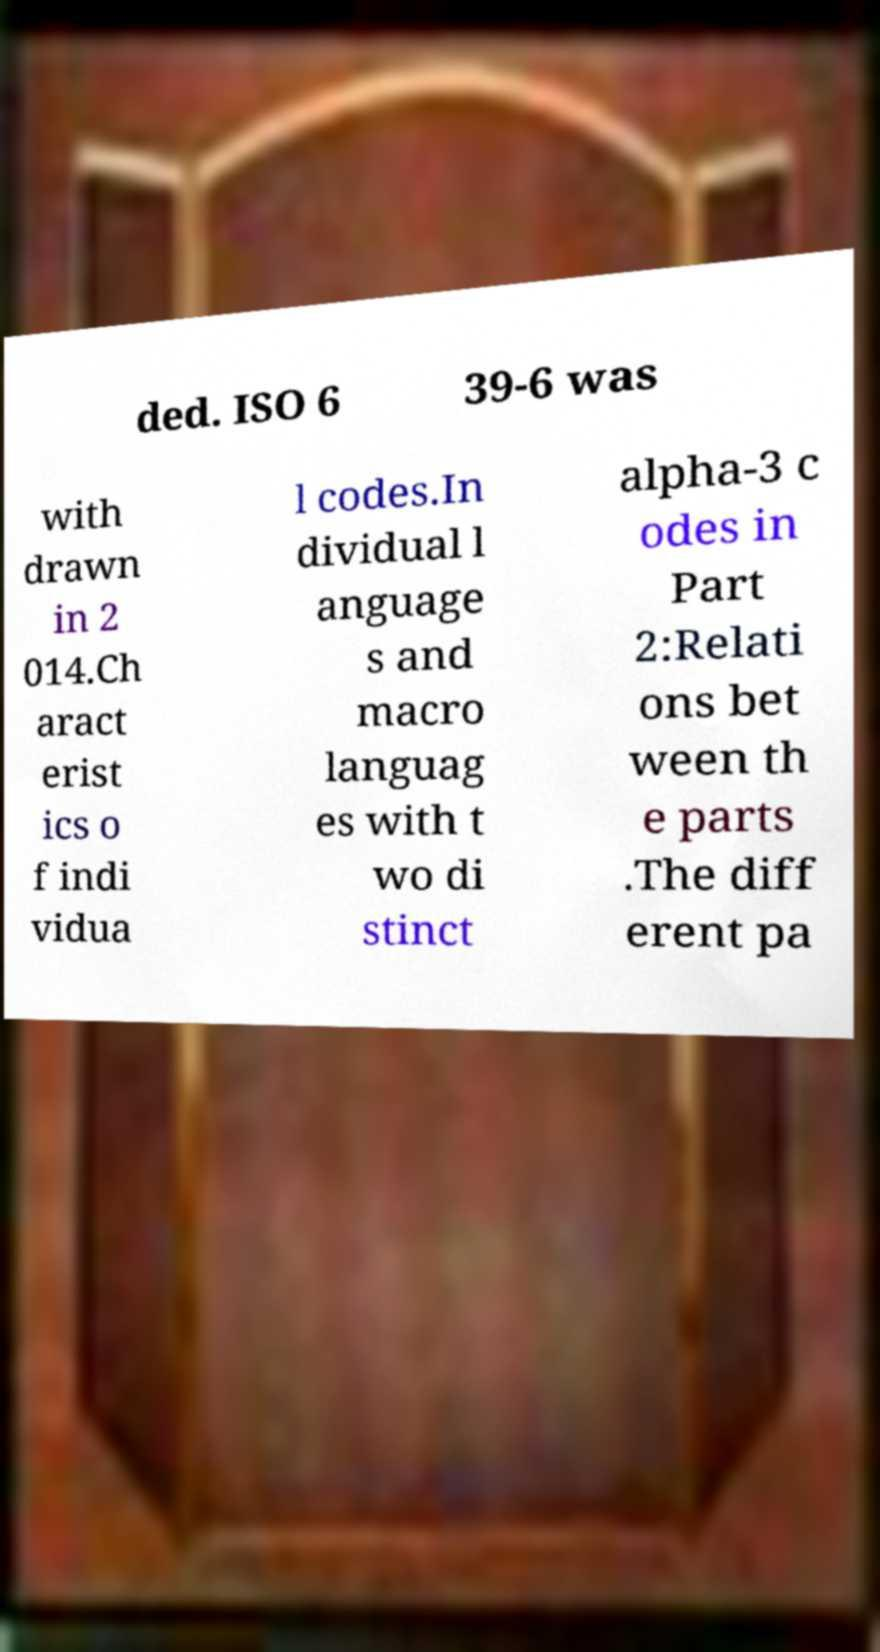For documentation purposes, I need the text within this image transcribed. Could you provide that? ded. ISO 6 39-6 was with drawn in 2 014.Ch aract erist ics o f indi vidua l codes.In dividual l anguage s and macro languag es with t wo di stinct alpha-3 c odes in Part 2:Relati ons bet ween th e parts .The diff erent pa 